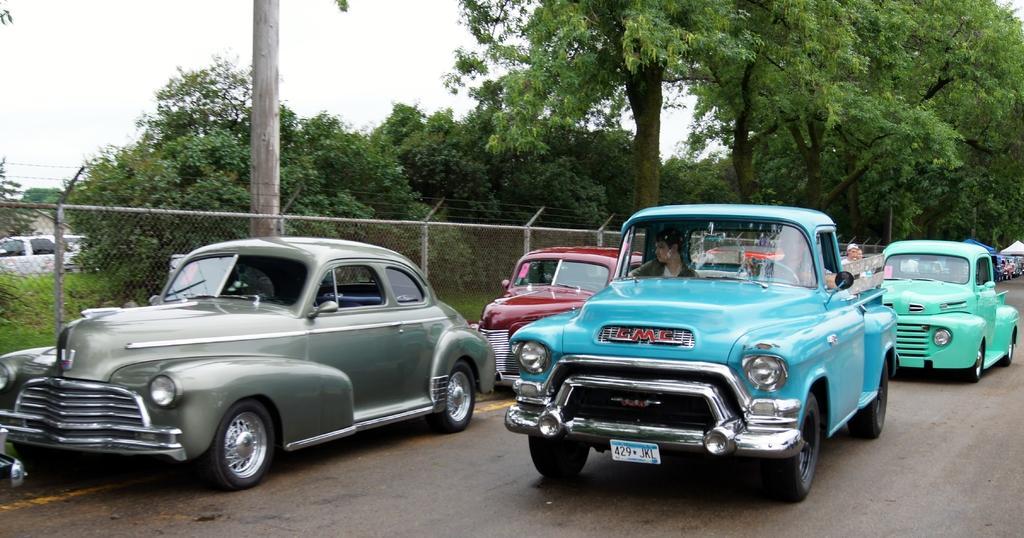In one or two sentences, can you explain what this image depicts? In this image in the center there are some vehicles, at the bottom there is road and in the background there are some people and some tents, trees. In the center there is a fence, trees, grass, vehicles. And at the top there is sky. 